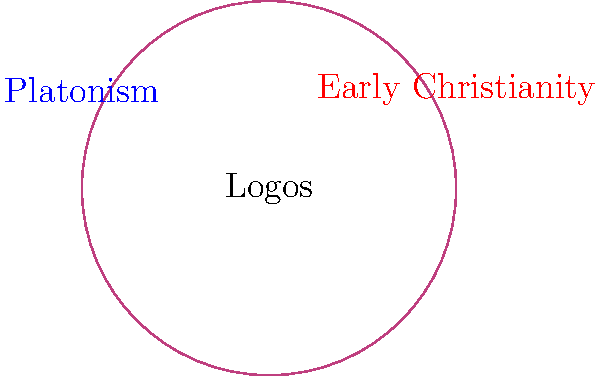How does the concept of the Logos serve as a bridge between Platonic philosophy and early Christian theology, as illustrated in the Venn diagram? Explain the significance of the overlapping area and its implications for the development of Christian doctrine. 1. Platonic concept of Logos:
   - In Platonism, the Logos represents divine reason or the rational principle governing the universe.
   - It is often associated with the realm of Forms and the intelligible world.

2. Early Christian adoption of Logos:
   - Early Christian thinkers, particularly in the Gospel of John, adopted the term Logos to describe Jesus Christ.
   - John 1:1 states, "In the beginning was the Word (Logos), and the Word was with God, and the Word was God."

3. Overlapping area (Synthesis):
   - The overlap represents the integration of Platonic ideas into Christian theology.
   - It illustrates how early Christian thinkers used Greek philosophical concepts to articulate their beliefs.

4. Significance of the synthesis:
   - Allowed for a more sophisticated articulation of Christian doctrine.
   - Helped bridge the gap between Greek philosophy and Christian theology.
   - Facilitated the spread of Christianity in the Hellenistic world.

5. Implications for Christian doctrine:
   - Influenced Christology: Understanding of Christ's divine nature.
   - Shaped Trinitarian theology: Logos as the second person of the Trinity.
   - Impacted the development of Christian Neoplatonism.

6. Key figures in this synthesis:
   - Philo of Alexandria: Jewish philosopher who first attempted to synthesize Jewish thought with Platonism.
   - Justin Martyr: Early Christian apologist who used the Logos concept to explain Christian beliefs to a Greek audience.
   - Origen: Christian theologian who further developed the Logos doctrine in a Platonic framework.

7. Challenges and debates:
   - Tension between maintaining Christian distinctiveness and adopting Greek philosophical concepts.
   - Debates over the nature of Christ and his relationship to God the Father.

8. Legacy:
   - The synthesis of Platonic Logos and Christian theology had a lasting impact on Western philosophy and theology.
   - It set the stage for later developments in Christian thought, including medieval scholasticism.
Answer: The Logos concept bridged Platonism and early Christianity by providing a philosophical framework to explain Christ's divine nature, facilitating the articulation of Christian doctrine in Hellenistic terms and influencing the development of Christology and Trinitarian theology. 